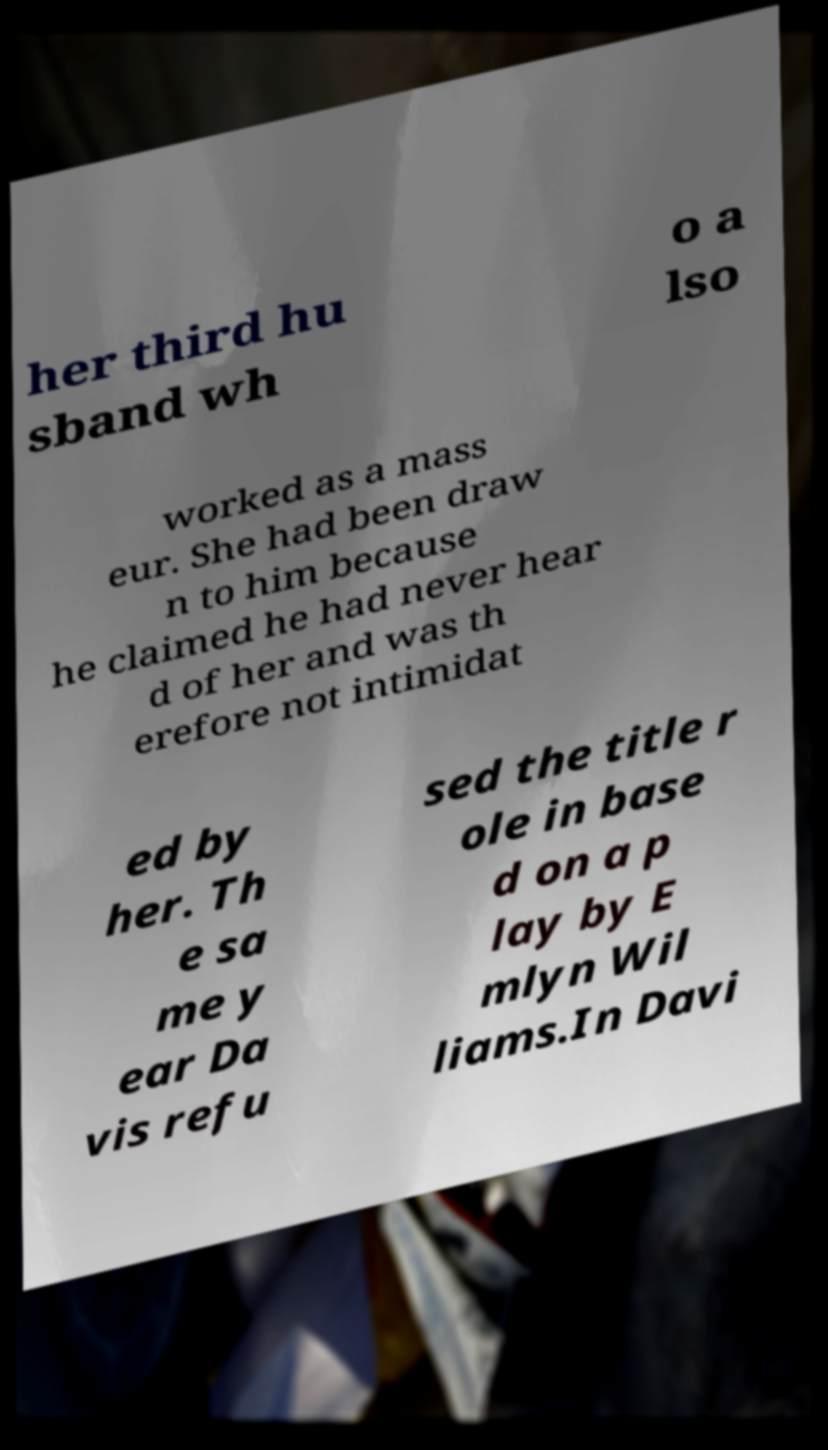For documentation purposes, I need the text within this image transcribed. Could you provide that? her third hu sband wh o a lso worked as a mass eur. She had been draw n to him because he claimed he had never hear d of her and was th erefore not intimidat ed by her. Th e sa me y ear Da vis refu sed the title r ole in base d on a p lay by E mlyn Wil liams.In Davi 